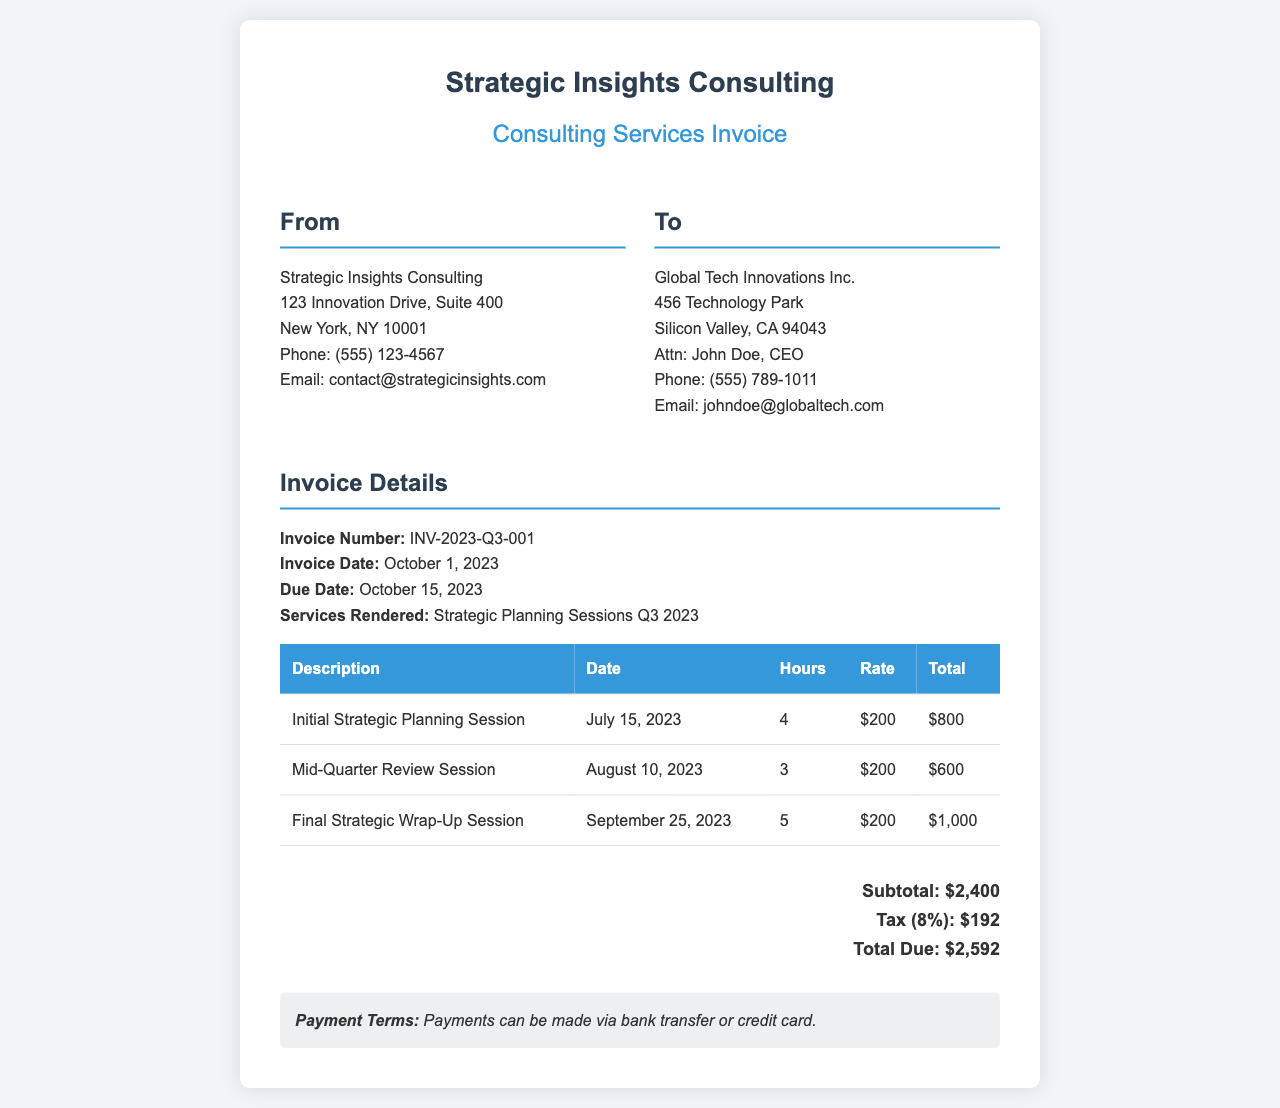What is the invoice number? The invoice number is a unique identifier for this invoice, which can be found in the document.
Answer: INV-2023-Q3-001 What is the total amount due? The total amount due is calculated by adding the subtotal and tax, which is specified in the document.
Answer: $2,592 Who is the client? The client is the entity that is receiving the invoice for services, listed in the document.
Answer: Global Tech Innovations Inc What was the date of the Final Strategic Wrap-Up Session? The date of the Final Strategic Wrap-Up Session is provided in the invoice under the description of the session.
Answer: September 25, 2023 What is the tax percentage applied? The tax percentage is mentioned in the invoice, showing how much tax is added to the subtotal.
Answer: 8% How many hours were worked in the Mid-Quarter Review Session? The number of hours worked for each session is detailed in the table, indicating hours for that session.
Answer: 3 What is the payment term mentioned in the invoice? The payment term specifies how the payment should be made, as stated at the end of the invoice.
Answer: Payments can be made via bank transfer or credit card What was the hour rate charged for the sessions? The rate charged is consistent across all sessions and is noted in the invoice's table.
Answer: $200 